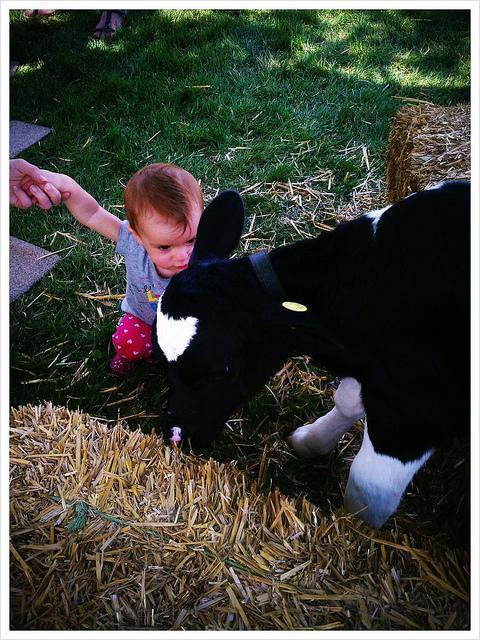What kind of food eater is the animal?
Pick the correct solution from the four options below to address the question.
Options: Carnivore, omnivore, herbivore, photosynthesis. Herbivore. 